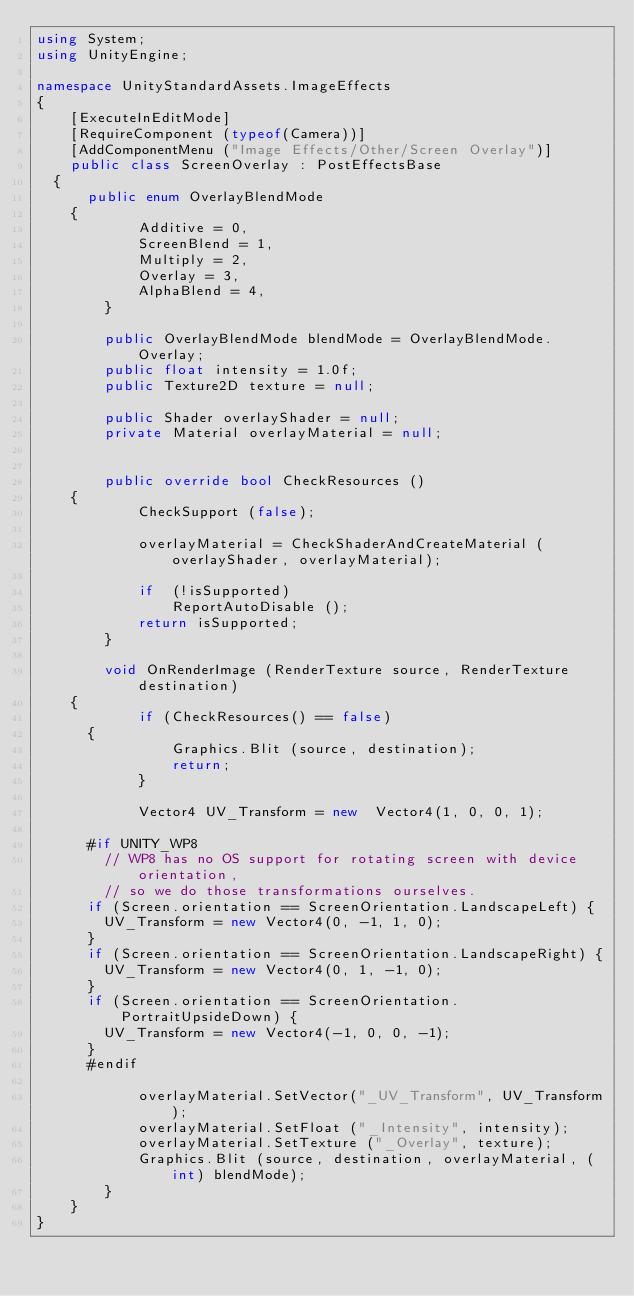Convert code to text. <code><loc_0><loc_0><loc_500><loc_500><_C#_>using System;
using UnityEngine;

namespace UnityStandardAssets.ImageEffects
{
    [ExecuteInEditMode]
    [RequireComponent (typeof(Camera))]
    [AddComponentMenu ("Image Effects/Other/Screen Overlay")]
    public class ScreenOverlay : PostEffectsBase
	{
	    public enum OverlayBlendMode
		{
            Additive = 0,
            ScreenBlend = 1,
            Multiply = 2,
            Overlay = 3,
            AlphaBlend = 4,
        }

        public OverlayBlendMode blendMode = OverlayBlendMode.Overlay;
        public float intensity = 1.0f;
        public Texture2D texture = null;

        public Shader overlayShader = null;
        private Material overlayMaterial = null;


        public override bool CheckResources ()
		{
            CheckSupport (false);

            overlayMaterial = CheckShaderAndCreateMaterial (overlayShader, overlayMaterial);

            if	(!isSupported)
                ReportAutoDisable ();
            return isSupported;
        }

        void OnRenderImage (RenderTexture source, RenderTexture destination)
		{
            if (CheckResources() == false)
			{
                Graphics.Blit (source, destination);
                return;
            }

            Vector4 UV_Transform = new  Vector4(1, 0, 0, 1);

			#if UNITY_WP8
	    	// WP8 has no OS support for rotating screen with device orientation,
	    	// so we do those transformations ourselves.
			if (Screen.orientation == ScreenOrientation.LandscapeLeft) {
				UV_Transform = new Vector4(0, -1, 1, 0);
			}
			if (Screen.orientation == ScreenOrientation.LandscapeRight) {
				UV_Transform = new Vector4(0, 1, -1, 0);
			}
			if (Screen.orientation == ScreenOrientation.PortraitUpsideDown) {
				UV_Transform = new Vector4(-1, 0, 0, -1);
			}
			#endif

            overlayMaterial.SetVector("_UV_Transform", UV_Transform);
            overlayMaterial.SetFloat ("_Intensity", intensity);
            overlayMaterial.SetTexture ("_Overlay", texture);
            Graphics.Blit (source, destination, overlayMaterial, (int) blendMode);
        }
    }
}
</code> 